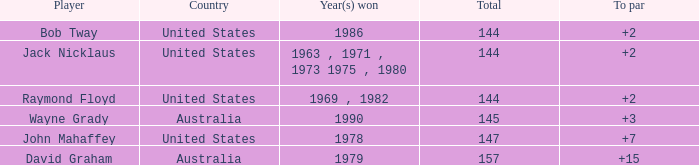How many strokes off par was the winner in 1978? 7.0. 